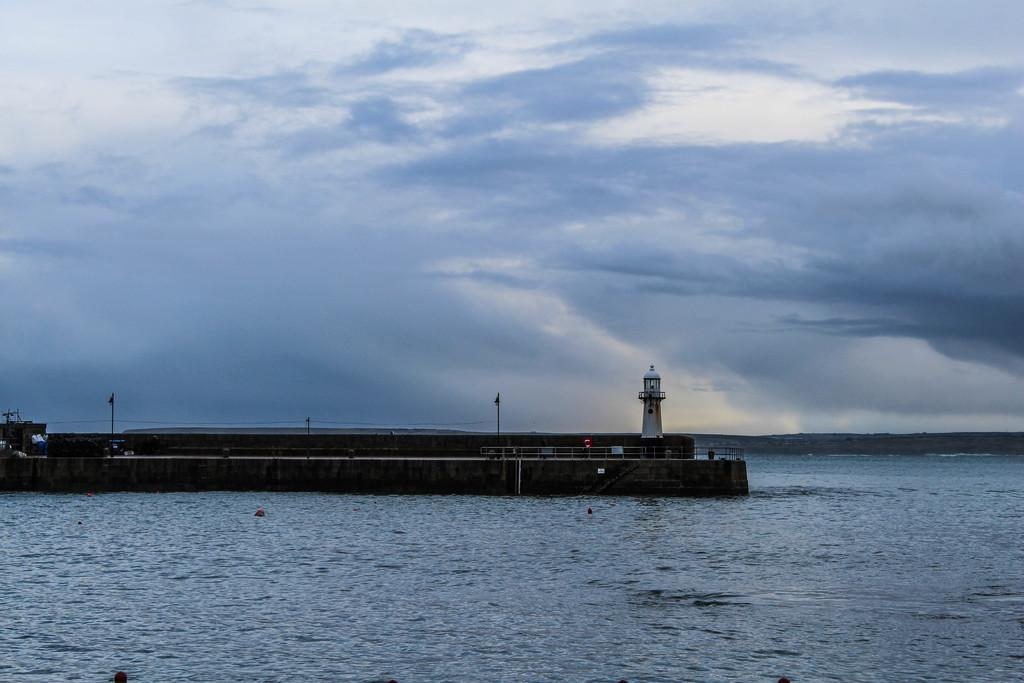What is visible in the image? Water is visible in the image. What can be seen in the background of the image? There is a lighthouse, poles, and railing in the background of the image. What is the color of the sky in the image? The sky is blue and white in color. How many women are riding on the ice in the image? There are no women or ice present in the image. 